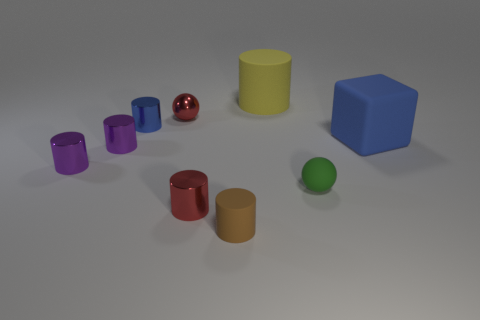What is the size of the green thing?
Keep it short and to the point. Small. There is a blue object that is the same size as the matte sphere; what material is it?
Offer a terse response. Metal. There is a ball behind the tiny green object; what color is it?
Your response must be concise. Red. What number of matte cylinders are there?
Provide a succinct answer. 2. There is a object that is behind the sphere that is left of the yellow rubber cylinder; is there a tiny red shiny cylinder in front of it?
Offer a very short reply. Yes. There is a green thing that is the same size as the blue metallic cylinder; what shape is it?
Give a very brief answer. Sphere. What number of other objects are the same color as the big rubber cube?
Keep it short and to the point. 1. What is the tiny red sphere made of?
Offer a terse response. Metal. What number of other things are made of the same material as the tiny red cylinder?
Give a very brief answer. 4. There is a shiny thing that is to the right of the blue cylinder and in front of the small blue cylinder; what size is it?
Give a very brief answer. Small. 